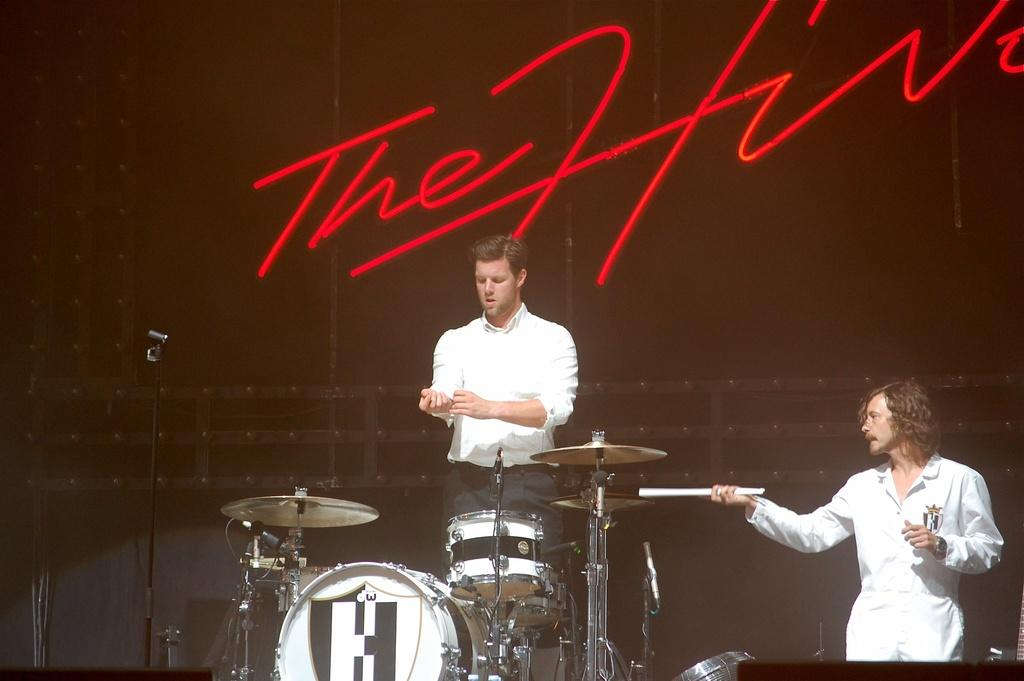How many people are in the image? There are two persons in the image. What objects are present that are typically used for amplifying sound? There are microphones in the image. What items are visible that are commonly used for creating music? There are musical instruments in the image. What color is the background of the image? The background of the image is black. Is there any text or writing visible in the image? Yes, there is writing on the background of the image. What type of alarm can be heard going off in the image? There is no alarm present or audible in the image. Can you tell me how many fangs are visible on the persons in the image? There are no fangs visible on the persons in the image. 